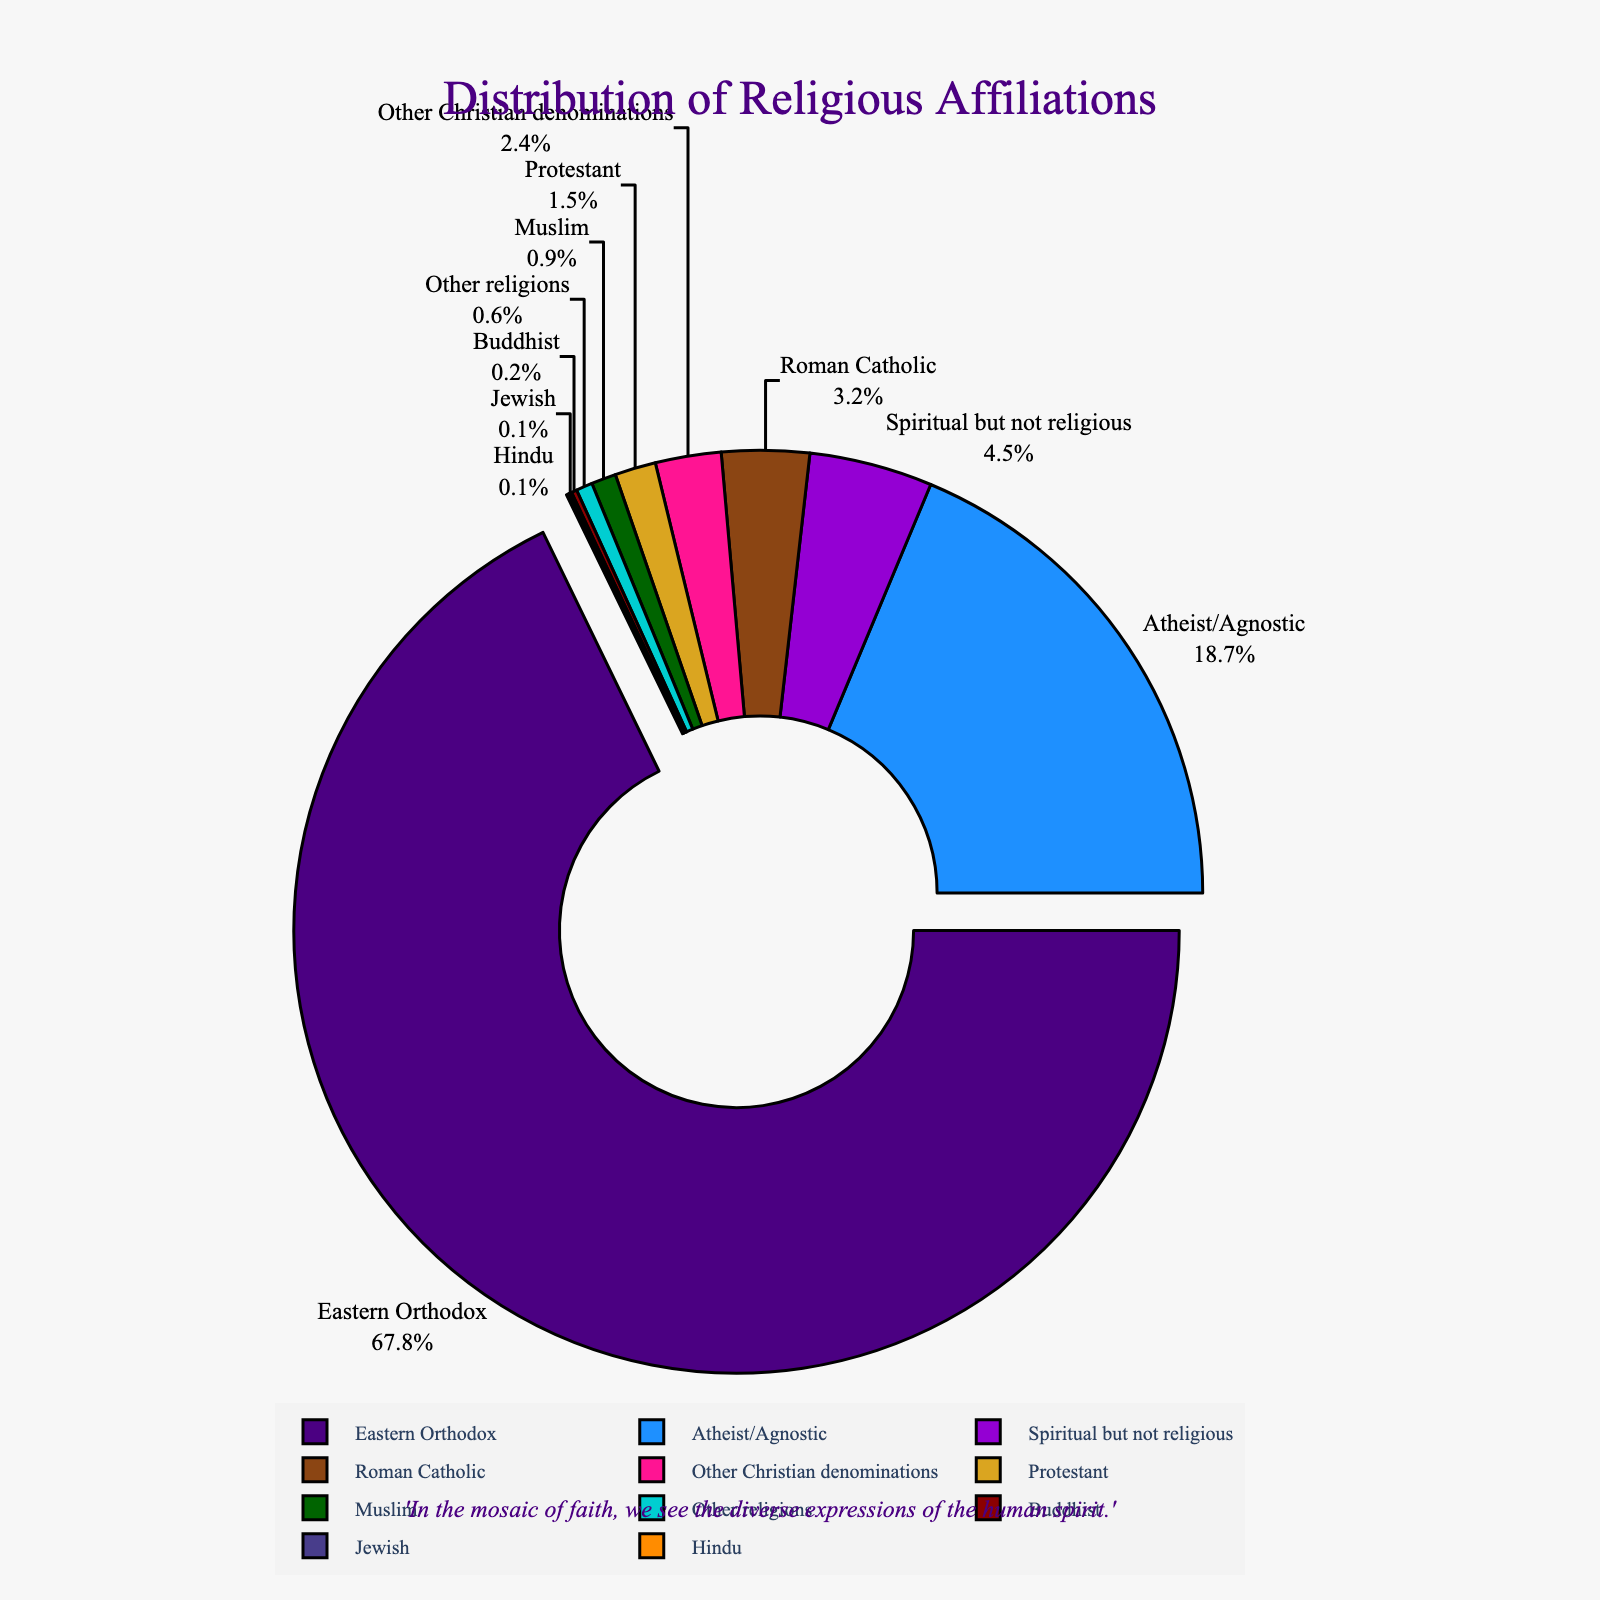What percentage of the population identifies as Eastern Orthodox? Look at the segment labeled "Eastern Orthodox" to find its corresponding percentage.
Answer: 67.8% Which religion has the smallest representation in the population? Examine the segment with the smallest slice, which is labeled "Jewish."
Answer: Jewish What is the combined percentage of Roman Catholic and Protestant populations? Identify the percentages of the Roman Catholic (3.2%) and Protestant (1.5%) segments and add them together: 3.2% + 1.5% = 4.7%.
Answer: 4.7% How does the percentage of people identified as Atheist/Agnostic compare to those identified as "Spiritual but not religious"? Compare the size of the "Atheist/Agnostic" segment (18.7%) with "Spiritual but not religious" (4.5%) and note that 18.7% is greater than 4.5%.
Answer: Atheist/Agnostic is greater Which segment has been visually emphasized in the figure, and why might this be? Identify the segment that is slightly pulled out from the center. The segment for "Eastern Orthodox" is pulled out due to its highest percentage (67.8%).
Answer: Eastern Orthodox What is the total percentage of the population that identifies with Christian denominations (Eastern Orthodox, Roman Catholic, Protestant, Other Christian denominations)? Sum the percentages of Eastern Orthodox (67.8%), Roman Catholic (3.2%), Protestant (1.5%), and Other Christian denominations (2.4%): 67.8% + 3.2% + 1.5% + 2.4% = 74.9%.
Answer: 74.9% Is the percentage of "Spiritual but not religious" higher or lower than that of "Other Christian denominations"? Compare the "Spiritual but not religious" percentage (4.5%) with "Other Christian denominations" (2.4%) and note that 4.5% is higher than 2.4%.
Answer: Higher Which segment of the pie chart is represented by the fifth color from the top in the legend? The fifth color from the top corresponds to the "Buddhist" segment.
Answer: Buddhist 